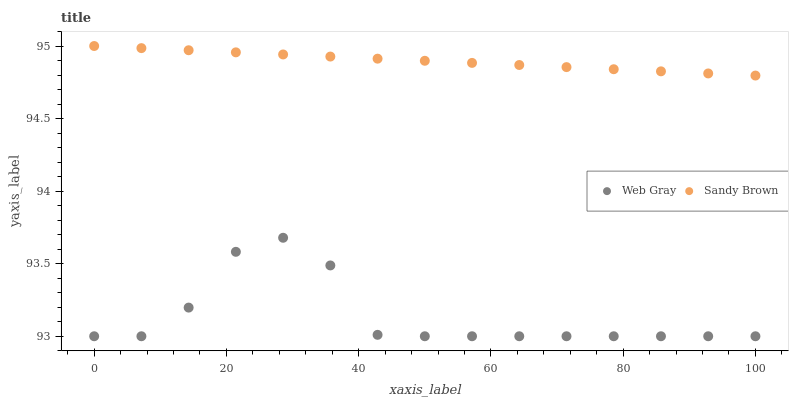Does Web Gray have the minimum area under the curve?
Answer yes or no. Yes. Does Sandy Brown have the maximum area under the curve?
Answer yes or no. Yes. Does Sandy Brown have the minimum area under the curve?
Answer yes or no. No. Is Sandy Brown the smoothest?
Answer yes or no. Yes. Is Web Gray the roughest?
Answer yes or no. Yes. Is Sandy Brown the roughest?
Answer yes or no. No. Does Web Gray have the lowest value?
Answer yes or no. Yes. Does Sandy Brown have the lowest value?
Answer yes or no. No. Does Sandy Brown have the highest value?
Answer yes or no. Yes. Is Web Gray less than Sandy Brown?
Answer yes or no. Yes. Is Sandy Brown greater than Web Gray?
Answer yes or no. Yes. Does Web Gray intersect Sandy Brown?
Answer yes or no. No. 